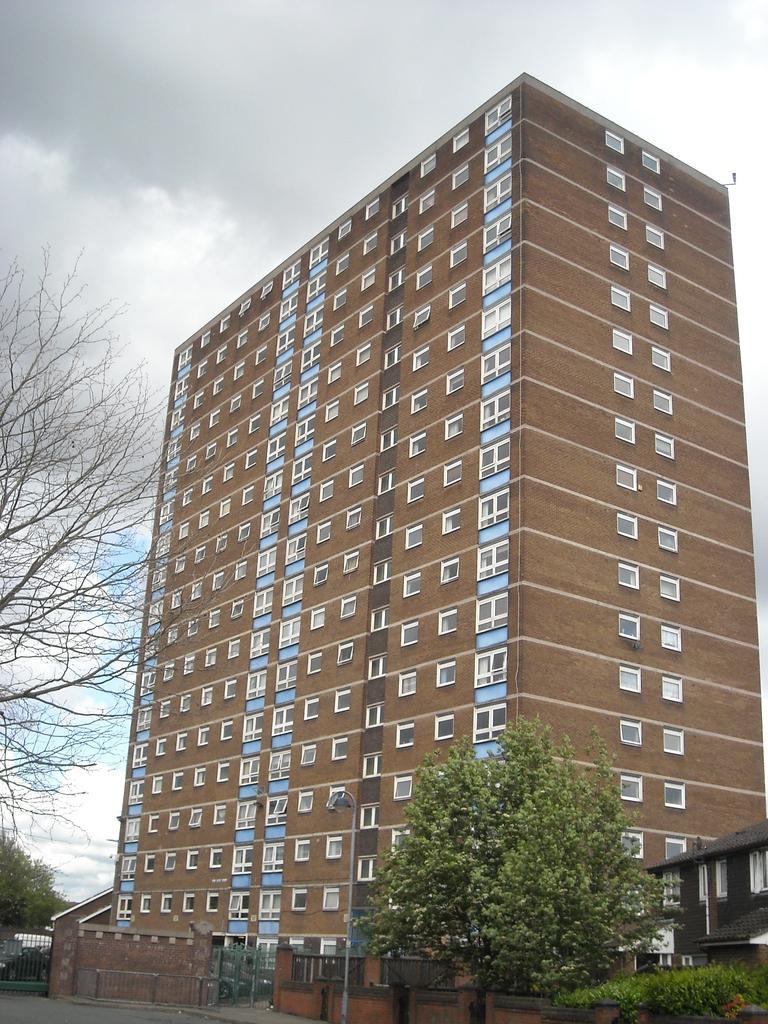Describe this image in one or two sentences. In this image we can see a building and a house, there are some trees, gates, plants, fence, windows and wall, in the background we can see the sky with clouds. 